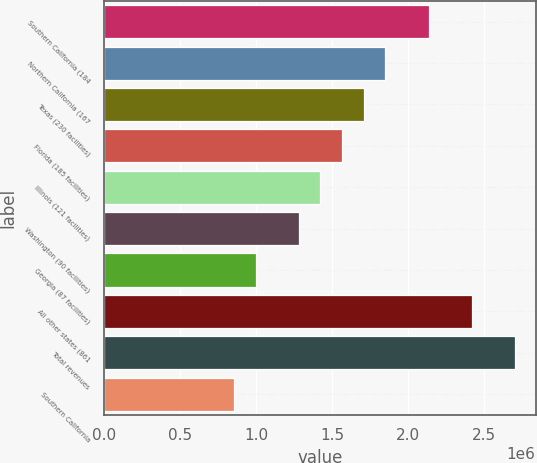Convert chart. <chart><loc_0><loc_0><loc_500><loc_500><bar_chart><fcel>Southern California (184<fcel>Northern California (167<fcel>Texas (230 facilities)<fcel>Florida (185 facilities)<fcel>Illinois (121 facilities)<fcel>Washington (90 facilities)<fcel>Georgia (87 facilities)<fcel>All other states (861<fcel>Total revenues<fcel>Southern California<nl><fcel>2.13496e+06<fcel>1.85031e+06<fcel>1.70799e+06<fcel>1.56566e+06<fcel>1.42334e+06<fcel>1.28101e+06<fcel>996363<fcel>2.41961e+06<fcel>2.70426e+06<fcel>854038<nl></chart> 